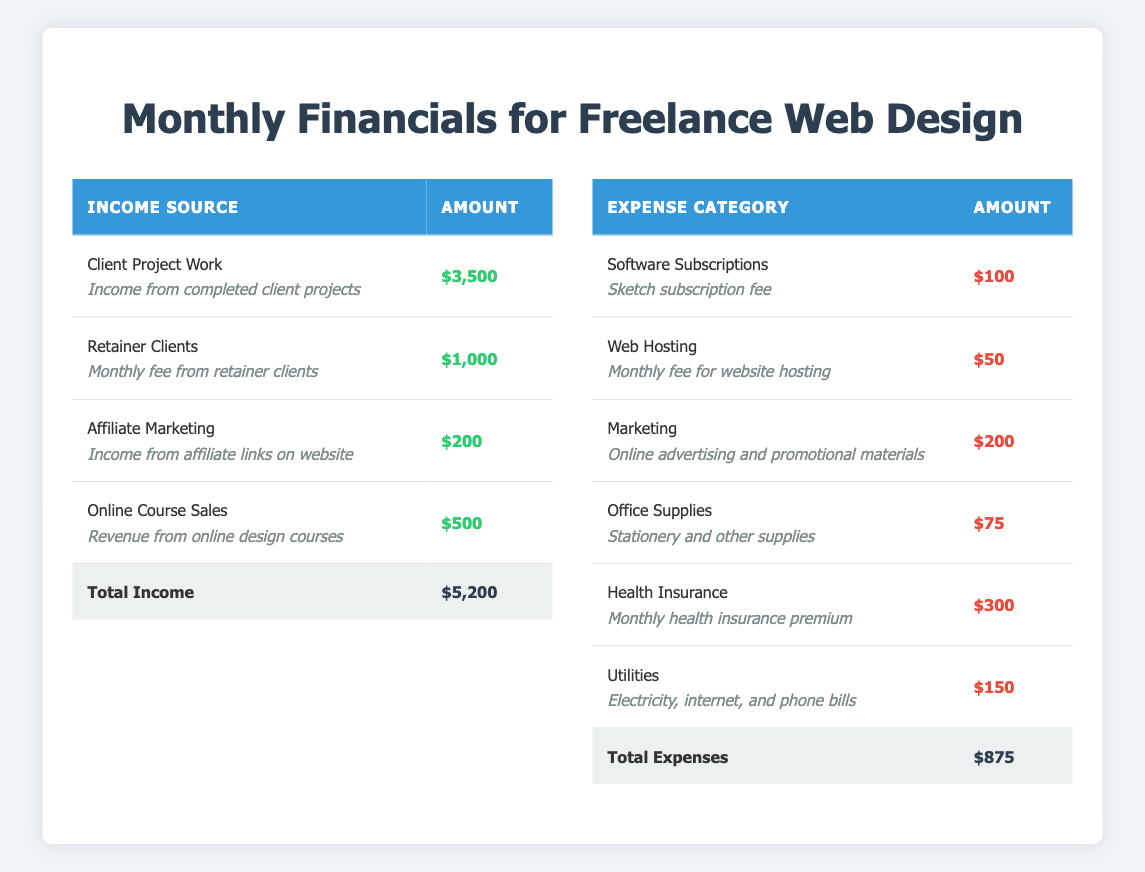What is the total income for the month? The total income is the sum of income from all sources: Client Project Work ($3500) + Retainer Clients ($1000) + Affiliate Marketing ($200) + Online Course Sales ($500) = $5200.
Answer: $5200 What is the largest expense category? The largest expense can be identified by comparing all the listed expenses: Software Subscriptions ($100), Web Hosting ($50), Marketing ($200), Office Supplies ($75), Health Insurance ($300), Utilities ($150). The highest amount is Health Insurance at $300.
Answer: Health Insurance Is the total income greater than the total expenses? Total income is $5200 and total expenses are $875. Since $5200 is greater than $875, the statement is true.
Answer: Yes What percentage of the total income do the expenses represent? To find the percentage, divide the total expenses by total income and multiply by 100: ($875 / $5200) x 100 = 16.88%.
Answer: 16.88% What is the difference between income from Client Project Work and online course sales? The income from Client Project Work is $3500, and Online Course Sales is $500. The difference is $3500 - $500 = $3000.
Answer: $3000 Which expense category accounts for the smallest amount? The smallest expense can be seen by comparing the amounts: Software Subscriptions ($100), Web Hosting ($50), Marketing ($200), Office Supplies ($75), Health Insurance ($300), Utilities ($150). The lowest is Web Hosting at $50.
Answer: Web Hosting How much more do you earn from Retainer Clients compared to Affiliate Marketing? The income from Retainer Clients is $1000 and from Affiliate Marketing is $200. The difference is $1000 - $200 = $800.
Answer: $800 Do total income and expenses balance each other? The total income is $5200 and total expenses are $875. Since they do not match, the statement is false.
Answer: No If you add your monthly income from Online Course Sales to the total expenses, what would the sum be? Total expenses are $875, and income from Online Course Sales is $500. The sum would be $875 + $500 = $1375.
Answer: $1375 